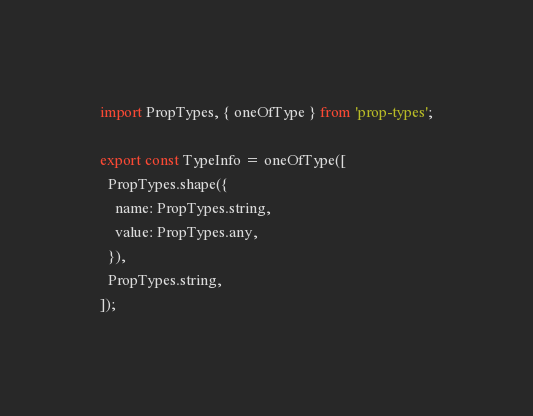<code> <loc_0><loc_0><loc_500><loc_500><_JavaScript_>import PropTypes, { oneOfType } from 'prop-types';

export const TypeInfo = oneOfType([
  PropTypes.shape({
    name: PropTypes.string,
    value: PropTypes.any,
  }),
  PropTypes.string,
]);
</code> 